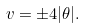<formula> <loc_0><loc_0><loc_500><loc_500>v = \pm 4 | \theta | .</formula> 